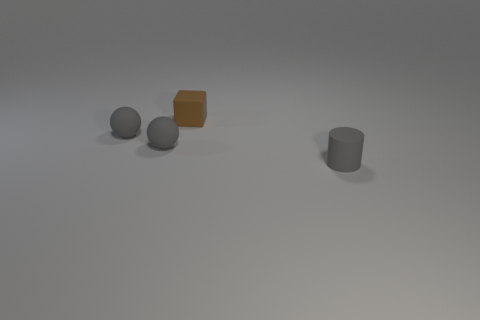Add 2 tiny brown things. How many objects exist? 6 Subtract all cylinders. How many objects are left? 3 Add 1 small green spheres. How many small green spheres exist? 1 Subtract 0 purple balls. How many objects are left? 4 Subtract all small brown things. Subtract all tiny red balls. How many objects are left? 3 Add 4 gray rubber things. How many gray rubber things are left? 7 